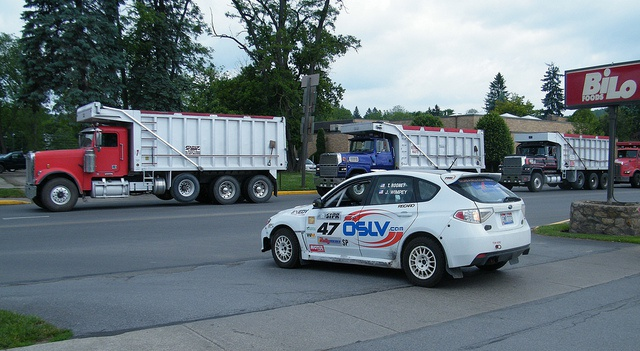Describe the objects in this image and their specific colors. I can see car in lightblue, black, and darkgray tones, truck in lightblue, black, and gray tones, truck in lightblue, black, darkgray, and gray tones, truck in lightblue, black, gray, darkgray, and navy tones, and truck in lightblue, black, maroon, and brown tones in this image. 